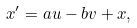Convert formula to latex. <formula><loc_0><loc_0><loc_500><loc_500>x ^ { \prime } = a u - b v + x ,</formula> 